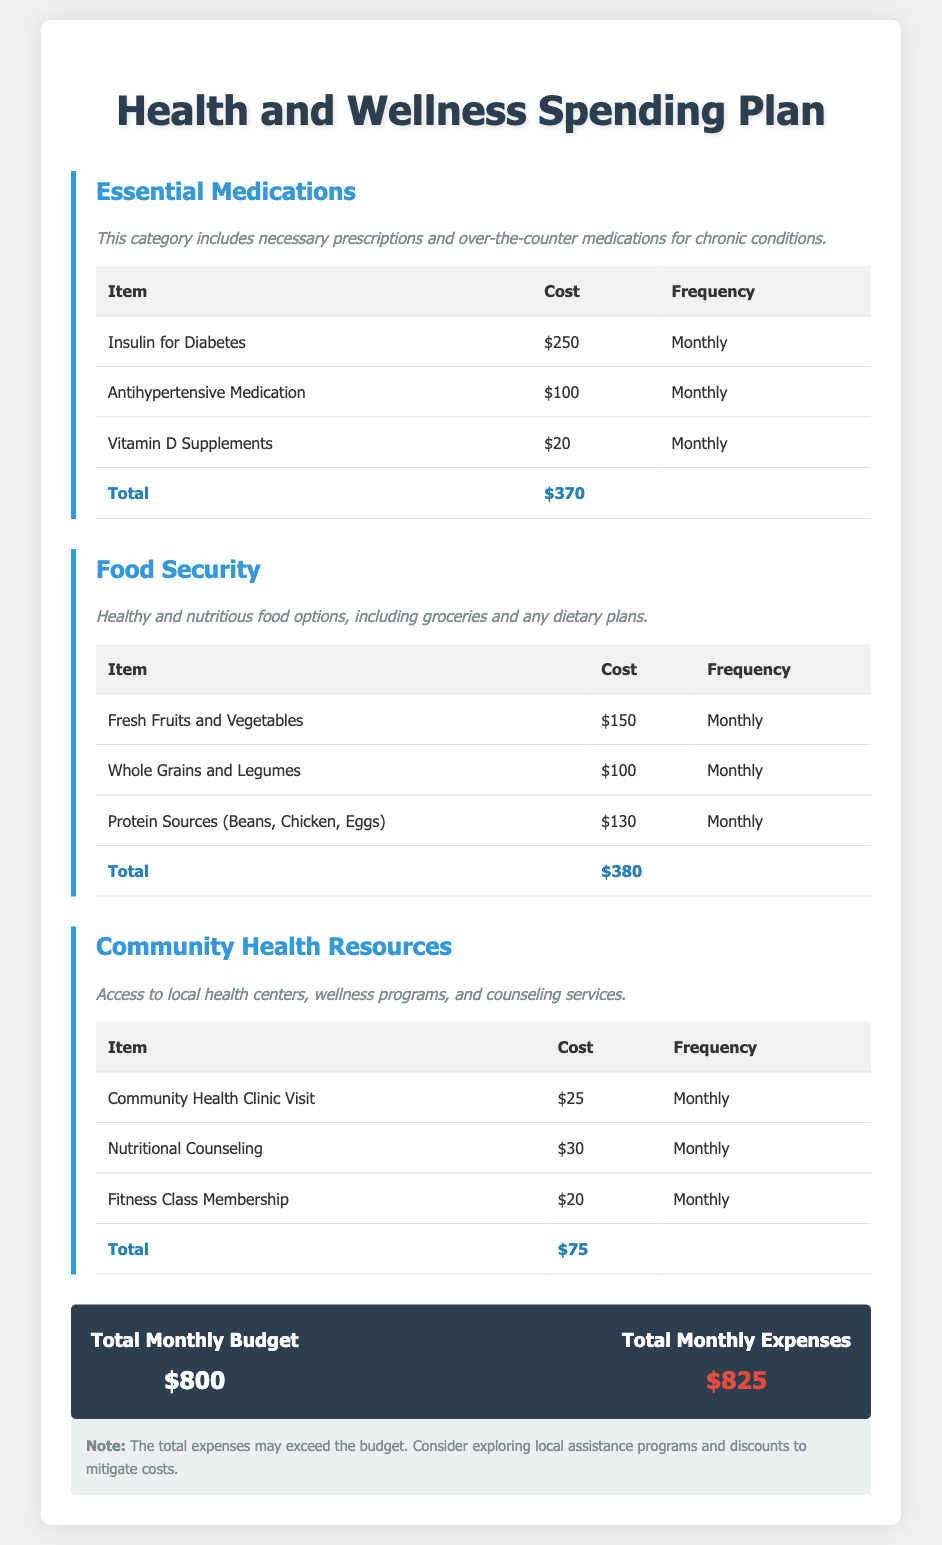what is the total cost for essential medications? The total cost for essential medications is given in the table under the "Total" row, which sums the costs of the items listed.
Answer: $370 what is the cost of fresh fruits and vegetables? The cost of fresh fruits and vegetables is listed in the food security section of the document.
Answer: $150 how often is insulin for diabetes purchased? The frequency for purchasing insulin is specified in the chart for essential medications.
Answer: Monthly what is the total monthly budget? The total monthly budget is presented in the budget summary section at the end of the document.
Answer: $800 how much do community health clinic visits cost? The document lists the cost specifically for community health clinic visits under community health resources.
Answer: $25 what is the total monthly expenses? The total monthly expenses are indicated in the budget summary section, combining all costs listed.
Answer: $825 how much does nutritional counseling cost monthly? Nutritional counseling is detailed in the community health resources section with its corresponding cost.
Answer: $30 what is the total cost for food security? The total cost for food security is shown under the total section in the food security category.
Answer: $380 are the total monthly expenses over or under budget? You can determine if the expenses are over or under budget by comparing the total expenses to the total budget amount.
Answer: Over 